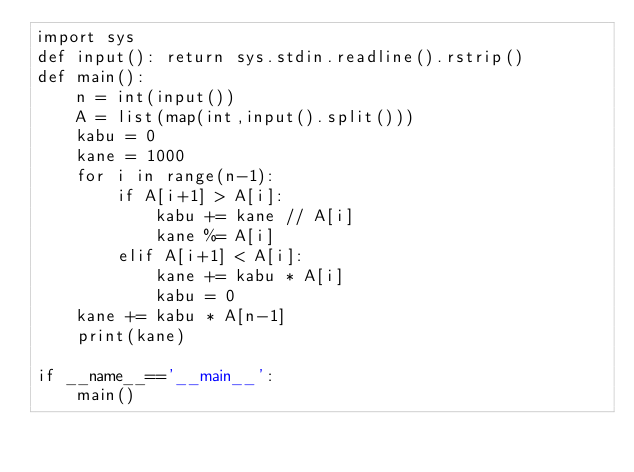<code> <loc_0><loc_0><loc_500><loc_500><_Python_>import sys
def input(): return sys.stdin.readline().rstrip()
def main():
    n = int(input())
    A = list(map(int,input().split()))
    kabu = 0
    kane = 1000
    for i in range(n-1):
        if A[i+1] > A[i]:
            kabu += kane // A[i]
            kane %= A[i]
        elif A[i+1] < A[i]:
            kane += kabu * A[i]
            kabu = 0
    kane += kabu * A[n-1]
    print(kane)

if __name__=='__main__':
    main()</code> 